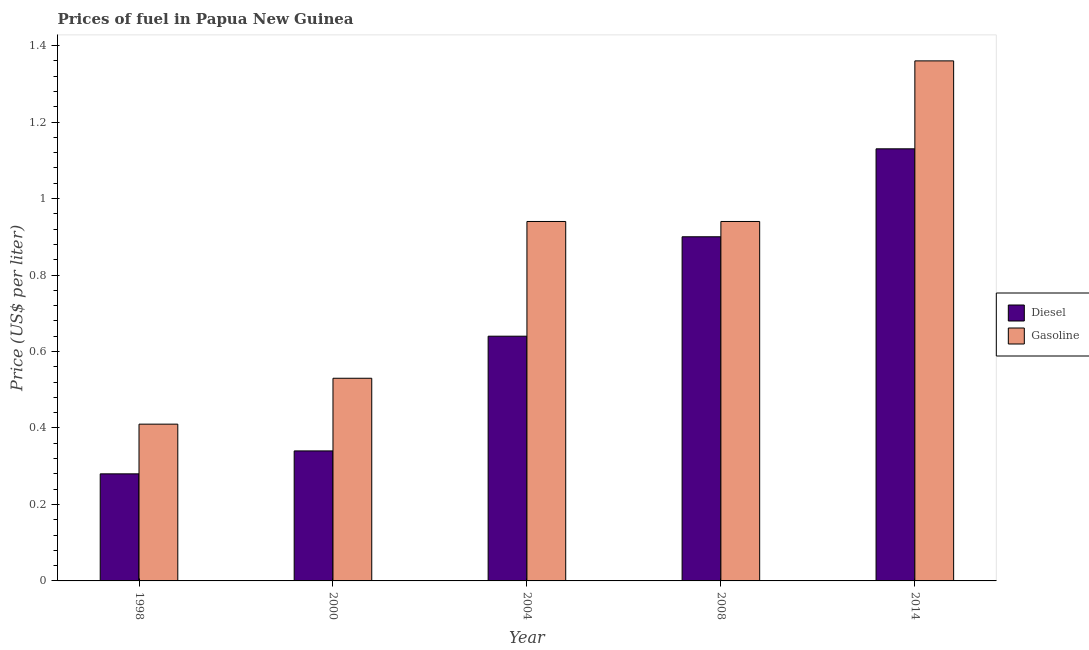How many bars are there on the 2nd tick from the left?
Keep it short and to the point. 2. What is the label of the 3rd group of bars from the left?
Make the answer very short. 2004. What is the diesel price in 1998?
Give a very brief answer. 0.28. Across all years, what is the maximum diesel price?
Provide a short and direct response. 1.13. Across all years, what is the minimum gasoline price?
Your answer should be very brief. 0.41. In which year was the diesel price maximum?
Ensure brevity in your answer.  2014. In which year was the diesel price minimum?
Make the answer very short. 1998. What is the total gasoline price in the graph?
Provide a short and direct response. 4.18. What is the difference between the diesel price in 1998 and that in 2000?
Your response must be concise. -0.06. What is the difference between the diesel price in 2004 and the gasoline price in 2014?
Offer a very short reply. -0.49. What is the average diesel price per year?
Your answer should be very brief. 0.66. In the year 2004, what is the difference between the diesel price and gasoline price?
Provide a succinct answer. 0. What is the ratio of the gasoline price in 1998 to that in 2008?
Offer a terse response. 0.44. What is the difference between the highest and the second highest diesel price?
Ensure brevity in your answer.  0.23. What is the difference between the highest and the lowest gasoline price?
Offer a very short reply. 0.95. In how many years, is the diesel price greater than the average diesel price taken over all years?
Give a very brief answer. 2. Is the sum of the diesel price in 2008 and 2014 greater than the maximum gasoline price across all years?
Your answer should be very brief. Yes. What does the 2nd bar from the left in 2004 represents?
Provide a short and direct response. Gasoline. What does the 2nd bar from the right in 2004 represents?
Provide a succinct answer. Diesel. How many bars are there?
Offer a terse response. 10. How many years are there in the graph?
Keep it short and to the point. 5. What is the difference between two consecutive major ticks on the Y-axis?
Offer a terse response. 0.2. Are the values on the major ticks of Y-axis written in scientific E-notation?
Your response must be concise. No. Where does the legend appear in the graph?
Provide a succinct answer. Center right. How many legend labels are there?
Give a very brief answer. 2. What is the title of the graph?
Provide a succinct answer. Prices of fuel in Papua New Guinea. What is the label or title of the X-axis?
Offer a very short reply. Year. What is the label or title of the Y-axis?
Provide a short and direct response. Price (US$ per liter). What is the Price (US$ per liter) in Diesel in 1998?
Keep it short and to the point. 0.28. What is the Price (US$ per liter) in Gasoline in 1998?
Ensure brevity in your answer.  0.41. What is the Price (US$ per liter) in Diesel in 2000?
Ensure brevity in your answer.  0.34. What is the Price (US$ per liter) in Gasoline in 2000?
Provide a succinct answer. 0.53. What is the Price (US$ per liter) in Diesel in 2004?
Your answer should be compact. 0.64. What is the Price (US$ per liter) of Diesel in 2014?
Make the answer very short. 1.13. What is the Price (US$ per liter) of Gasoline in 2014?
Provide a succinct answer. 1.36. Across all years, what is the maximum Price (US$ per liter) of Diesel?
Your answer should be compact. 1.13. Across all years, what is the maximum Price (US$ per liter) in Gasoline?
Your response must be concise. 1.36. Across all years, what is the minimum Price (US$ per liter) in Diesel?
Offer a very short reply. 0.28. Across all years, what is the minimum Price (US$ per liter) in Gasoline?
Make the answer very short. 0.41. What is the total Price (US$ per liter) of Diesel in the graph?
Offer a terse response. 3.29. What is the total Price (US$ per liter) of Gasoline in the graph?
Your answer should be very brief. 4.18. What is the difference between the Price (US$ per liter) in Diesel in 1998 and that in 2000?
Keep it short and to the point. -0.06. What is the difference between the Price (US$ per liter) of Gasoline in 1998 and that in 2000?
Give a very brief answer. -0.12. What is the difference between the Price (US$ per liter) of Diesel in 1998 and that in 2004?
Make the answer very short. -0.36. What is the difference between the Price (US$ per liter) in Gasoline in 1998 and that in 2004?
Offer a terse response. -0.53. What is the difference between the Price (US$ per liter) in Diesel in 1998 and that in 2008?
Give a very brief answer. -0.62. What is the difference between the Price (US$ per liter) in Gasoline in 1998 and that in 2008?
Offer a very short reply. -0.53. What is the difference between the Price (US$ per liter) of Diesel in 1998 and that in 2014?
Your response must be concise. -0.85. What is the difference between the Price (US$ per liter) in Gasoline in 1998 and that in 2014?
Offer a very short reply. -0.95. What is the difference between the Price (US$ per liter) in Gasoline in 2000 and that in 2004?
Provide a succinct answer. -0.41. What is the difference between the Price (US$ per liter) in Diesel in 2000 and that in 2008?
Offer a very short reply. -0.56. What is the difference between the Price (US$ per liter) in Gasoline in 2000 and that in 2008?
Your answer should be very brief. -0.41. What is the difference between the Price (US$ per liter) of Diesel in 2000 and that in 2014?
Offer a terse response. -0.79. What is the difference between the Price (US$ per liter) of Gasoline in 2000 and that in 2014?
Offer a terse response. -0.83. What is the difference between the Price (US$ per liter) of Diesel in 2004 and that in 2008?
Provide a succinct answer. -0.26. What is the difference between the Price (US$ per liter) of Gasoline in 2004 and that in 2008?
Make the answer very short. 0. What is the difference between the Price (US$ per liter) in Diesel in 2004 and that in 2014?
Offer a terse response. -0.49. What is the difference between the Price (US$ per liter) of Gasoline in 2004 and that in 2014?
Your answer should be very brief. -0.42. What is the difference between the Price (US$ per liter) of Diesel in 2008 and that in 2014?
Provide a succinct answer. -0.23. What is the difference between the Price (US$ per liter) of Gasoline in 2008 and that in 2014?
Your answer should be compact. -0.42. What is the difference between the Price (US$ per liter) of Diesel in 1998 and the Price (US$ per liter) of Gasoline in 2000?
Keep it short and to the point. -0.25. What is the difference between the Price (US$ per liter) in Diesel in 1998 and the Price (US$ per liter) in Gasoline in 2004?
Keep it short and to the point. -0.66. What is the difference between the Price (US$ per liter) of Diesel in 1998 and the Price (US$ per liter) of Gasoline in 2008?
Provide a succinct answer. -0.66. What is the difference between the Price (US$ per liter) in Diesel in 1998 and the Price (US$ per liter) in Gasoline in 2014?
Give a very brief answer. -1.08. What is the difference between the Price (US$ per liter) of Diesel in 2000 and the Price (US$ per liter) of Gasoline in 2004?
Make the answer very short. -0.6. What is the difference between the Price (US$ per liter) of Diesel in 2000 and the Price (US$ per liter) of Gasoline in 2008?
Your answer should be very brief. -0.6. What is the difference between the Price (US$ per liter) of Diesel in 2000 and the Price (US$ per liter) of Gasoline in 2014?
Provide a short and direct response. -1.02. What is the difference between the Price (US$ per liter) of Diesel in 2004 and the Price (US$ per liter) of Gasoline in 2014?
Keep it short and to the point. -0.72. What is the difference between the Price (US$ per liter) of Diesel in 2008 and the Price (US$ per liter) of Gasoline in 2014?
Your answer should be compact. -0.46. What is the average Price (US$ per liter) of Diesel per year?
Give a very brief answer. 0.66. What is the average Price (US$ per liter) in Gasoline per year?
Give a very brief answer. 0.84. In the year 1998, what is the difference between the Price (US$ per liter) in Diesel and Price (US$ per liter) in Gasoline?
Your answer should be compact. -0.13. In the year 2000, what is the difference between the Price (US$ per liter) of Diesel and Price (US$ per liter) of Gasoline?
Your answer should be compact. -0.19. In the year 2008, what is the difference between the Price (US$ per liter) in Diesel and Price (US$ per liter) in Gasoline?
Provide a short and direct response. -0.04. In the year 2014, what is the difference between the Price (US$ per liter) of Diesel and Price (US$ per liter) of Gasoline?
Make the answer very short. -0.23. What is the ratio of the Price (US$ per liter) of Diesel in 1998 to that in 2000?
Offer a very short reply. 0.82. What is the ratio of the Price (US$ per liter) of Gasoline in 1998 to that in 2000?
Your response must be concise. 0.77. What is the ratio of the Price (US$ per liter) in Diesel in 1998 to that in 2004?
Ensure brevity in your answer.  0.44. What is the ratio of the Price (US$ per liter) in Gasoline in 1998 to that in 2004?
Your response must be concise. 0.44. What is the ratio of the Price (US$ per liter) of Diesel in 1998 to that in 2008?
Ensure brevity in your answer.  0.31. What is the ratio of the Price (US$ per liter) in Gasoline in 1998 to that in 2008?
Provide a succinct answer. 0.44. What is the ratio of the Price (US$ per liter) of Diesel in 1998 to that in 2014?
Make the answer very short. 0.25. What is the ratio of the Price (US$ per liter) of Gasoline in 1998 to that in 2014?
Make the answer very short. 0.3. What is the ratio of the Price (US$ per liter) of Diesel in 2000 to that in 2004?
Offer a very short reply. 0.53. What is the ratio of the Price (US$ per liter) in Gasoline in 2000 to that in 2004?
Offer a very short reply. 0.56. What is the ratio of the Price (US$ per liter) of Diesel in 2000 to that in 2008?
Ensure brevity in your answer.  0.38. What is the ratio of the Price (US$ per liter) in Gasoline in 2000 to that in 2008?
Make the answer very short. 0.56. What is the ratio of the Price (US$ per liter) in Diesel in 2000 to that in 2014?
Ensure brevity in your answer.  0.3. What is the ratio of the Price (US$ per liter) in Gasoline in 2000 to that in 2014?
Ensure brevity in your answer.  0.39. What is the ratio of the Price (US$ per liter) of Diesel in 2004 to that in 2008?
Provide a short and direct response. 0.71. What is the ratio of the Price (US$ per liter) of Gasoline in 2004 to that in 2008?
Give a very brief answer. 1. What is the ratio of the Price (US$ per liter) in Diesel in 2004 to that in 2014?
Offer a very short reply. 0.57. What is the ratio of the Price (US$ per liter) of Gasoline in 2004 to that in 2014?
Your response must be concise. 0.69. What is the ratio of the Price (US$ per liter) of Diesel in 2008 to that in 2014?
Your answer should be compact. 0.8. What is the ratio of the Price (US$ per liter) in Gasoline in 2008 to that in 2014?
Give a very brief answer. 0.69. What is the difference between the highest and the second highest Price (US$ per liter) of Diesel?
Your answer should be compact. 0.23. What is the difference between the highest and the second highest Price (US$ per liter) of Gasoline?
Your answer should be compact. 0.42. What is the difference between the highest and the lowest Price (US$ per liter) in Gasoline?
Ensure brevity in your answer.  0.95. 